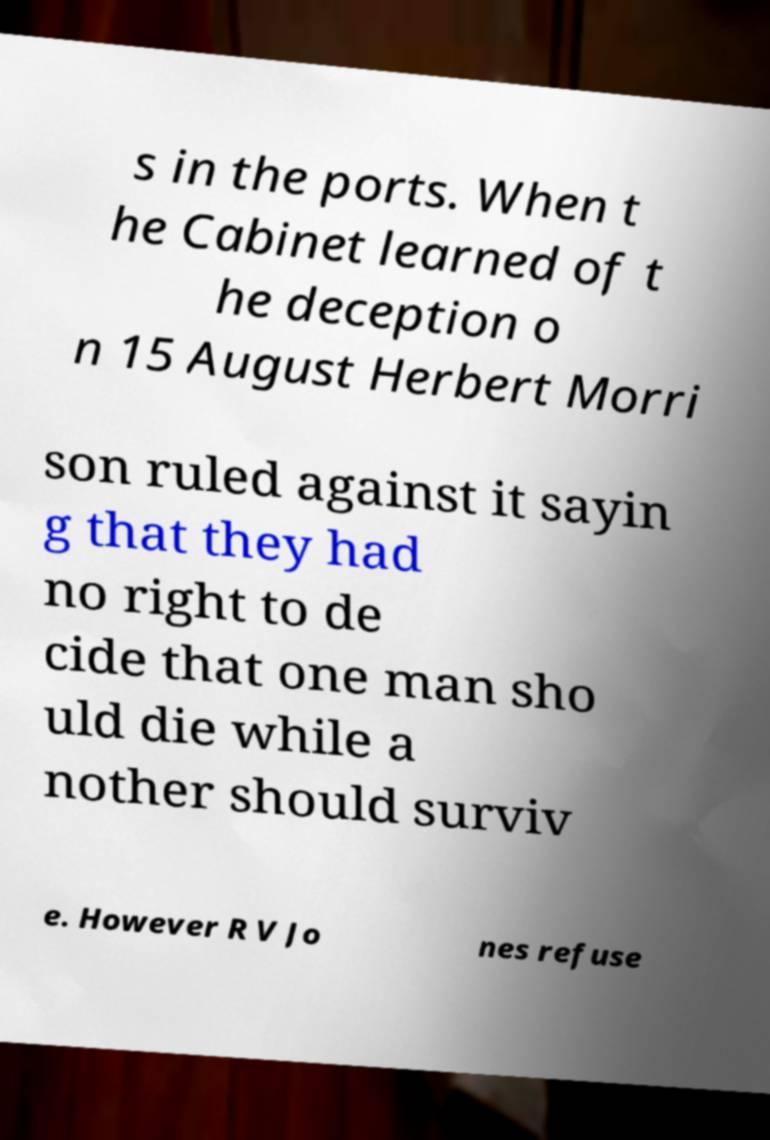What messages or text are displayed in this image? I need them in a readable, typed format. s in the ports. When t he Cabinet learned of t he deception o n 15 August Herbert Morri son ruled against it sayin g that they had no right to de cide that one man sho uld die while a nother should surviv e. However R V Jo nes refuse 